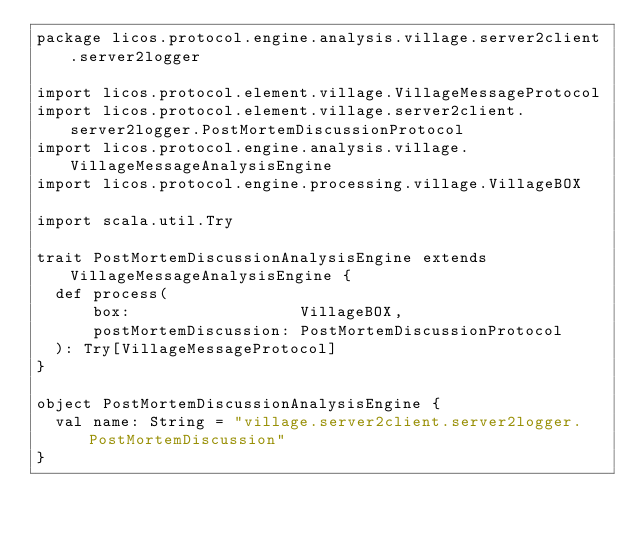Convert code to text. <code><loc_0><loc_0><loc_500><loc_500><_Scala_>package licos.protocol.engine.analysis.village.server2client.server2logger

import licos.protocol.element.village.VillageMessageProtocol
import licos.protocol.element.village.server2client.server2logger.PostMortemDiscussionProtocol
import licos.protocol.engine.analysis.village.VillageMessageAnalysisEngine
import licos.protocol.engine.processing.village.VillageBOX

import scala.util.Try

trait PostMortemDiscussionAnalysisEngine extends VillageMessageAnalysisEngine {
  def process(
      box:                  VillageBOX,
      postMortemDiscussion: PostMortemDiscussionProtocol
  ): Try[VillageMessageProtocol]
}

object PostMortemDiscussionAnalysisEngine {
  val name: String = "village.server2client.server2logger.PostMortemDiscussion"
}
</code> 